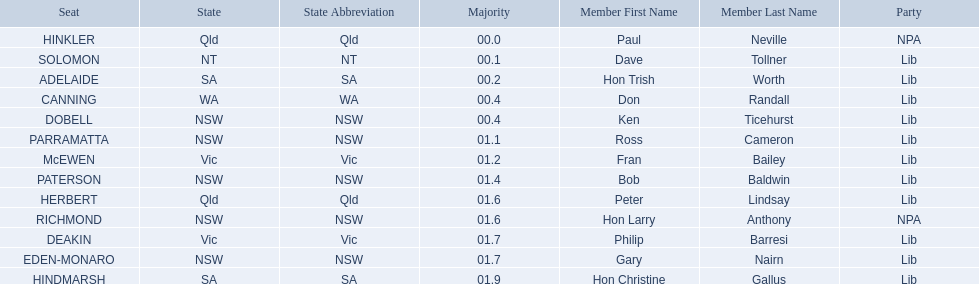What state does hinkler belong too? Qld. What is the majority of difference between sa and qld? 01.9. 